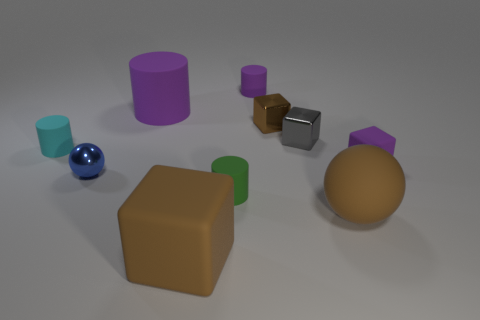Subtract 1 blocks. How many blocks are left? 3 Subtract all cylinders. How many objects are left? 6 Subtract 0 gray spheres. How many objects are left? 10 Subtract all brown shiny things. Subtract all big cylinders. How many objects are left? 8 Add 7 blue objects. How many blue objects are left? 8 Add 10 small red metallic cylinders. How many small red metallic cylinders exist? 10 